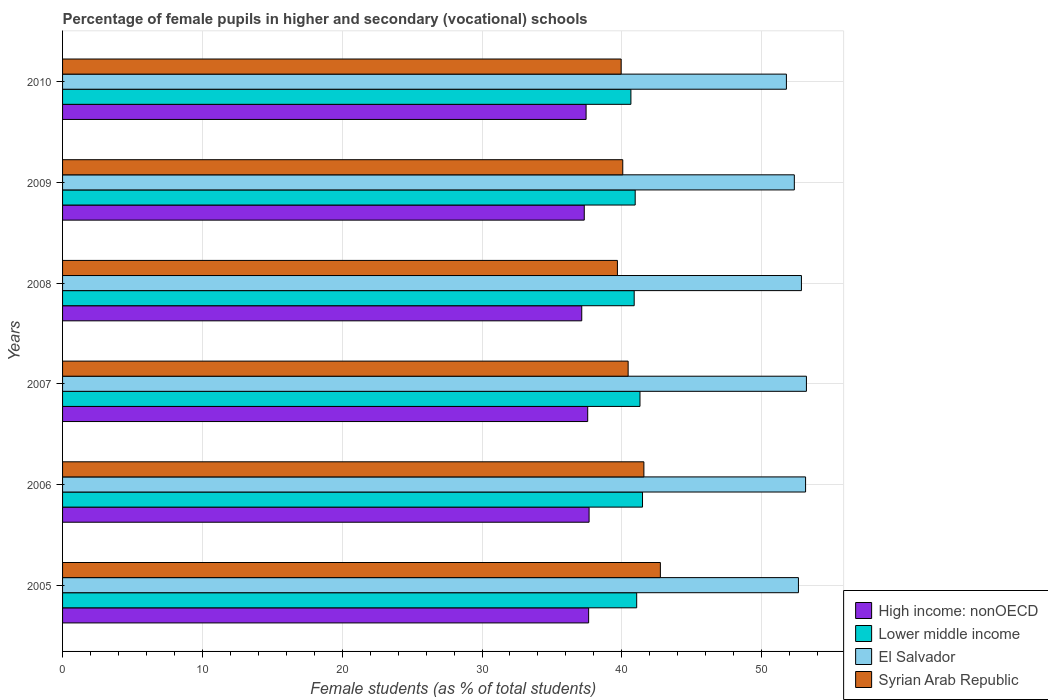Are the number of bars per tick equal to the number of legend labels?
Your response must be concise. Yes. What is the label of the 1st group of bars from the top?
Provide a short and direct response. 2010. What is the percentage of female pupils in higher and secondary schools in El Salvador in 2008?
Make the answer very short. 52.85. Across all years, what is the maximum percentage of female pupils in higher and secondary schools in Syrian Arab Republic?
Provide a short and direct response. 42.76. Across all years, what is the minimum percentage of female pupils in higher and secondary schools in High income: nonOECD?
Give a very brief answer. 37.14. In which year was the percentage of female pupils in higher and secondary schools in Lower middle income maximum?
Ensure brevity in your answer.  2006. In which year was the percentage of female pupils in higher and secondary schools in Lower middle income minimum?
Your answer should be compact. 2010. What is the total percentage of female pupils in higher and secondary schools in El Salvador in the graph?
Keep it short and to the point. 315.95. What is the difference between the percentage of female pupils in higher and secondary schools in Syrian Arab Republic in 2008 and that in 2010?
Keep it short and to the point. -0.27. What is the difference between the percentage of female pupils in higher and secondary schools in Syrian Arab Republic in 2008 and the percentage of female pupils in higher and secondary schools in El Salvador in 2007?
Keep it short and to the point. -13.52. What is the average percentage of female pupils in higher and secondary schools in High income: nonOECD per year?
Provide a short and direct response. 37.46. In the year 2009, what is the difference between the percentage of female pupils in higher and secondary schools in High income: nonOECD and percentage of female pupils in higher and secondary schools in Lower middle income?
Ensure brevity in your answer.  -3.64. What is the ratio of the percentage of female pupils in higher and secondary schools in Lower middle income in 2006 to that in 2007?
Provide a succinct answer. 1. Is the percentage of female pupils in higher and secondary schools in High income: nonOECD in 2008 less than that in 2010?
Make the answer very short. Yes. What is the difference between the highest and the second highest percentage of female pupils in higher and secondary schools in Syrian Arab Republic?
Provide a short and direct response. 1.18. What is the difference between the highest and the lowest percentage of female pupils in higher and secondary schools in Lower middle income?
Ensure brevity in your answer.  0.83. Is the sum of the percentage of female pupils in higher and secondary schools in Syrian Arab Republic in 2006 and 2007 greater than the maximum percentage of female pupils in higher and secondary schools in High income: nonOECD across all years?
Your answer should be very brief. Yes. What does the 4th bar from the top in 2008 represents?
Your answer should be very brief. High income: nonOECD. What does the 1st bar from the bottom in 2005 represents?
Offer a terse response. High income: nonOECD. Is it the case that in every year, the sum of the percentage of female pupils in higher and secondary schools in Syrian Arab Republic and percentage of female pupils in higher and secondary schools in El Salvador is greater than the percentage of female pupils in higher and secondary schools in High income: nonOECD?
Offer a very short reply. Yes. What is the difference between two consecutive major ticks on the X-axis?
Offer a terse response. 10. Does the graph contain grids?
Ensure brevity in your answer.  Yes. Where does the legend appear in the graph?
Your answer should be very brief. Bottom right. How many legend labels are there?
Offer a very short reply. 4. How are the legend labels stacked?
Offer a terse response. Vertical. What is the title of the graph?
Offer a very short reply. Percentage of female pupils in higher and secondary (vocational) schools. Does "Papua New Guinea" appear as one of the legend labels in the graph?
Keep it short and to the point. No. What is the label or title of the X-axis?
Provide a succinct answer. Female students (as % of total students). What is the label or title of the Y-axis?
Keep it short and to the point. Years. What is the Female students (as % of total students) in High income: nonOECD in 2005?
Give a very brief answer. 37.63. What is the Female students (as % of total students) of Lower middle income in 2005?
Ensure brevity in your answer.  41.06. What is the Female students (as % of total students) of El Salvador in 2005?
Provide a succinct answer. 52.63. What is the Female students (as % of total students) of Syrian Arab Republic in 2005?
Your response must be concise. 42.76. What is the Female students (as % of total students) of High income: nonOECD in 2006?
Give a very brief answer. 37.66. What is the Female students (as % of total students) in Lower middle income in 2006?
Keep it short and to the point. 41.48. What is the Female students (as % of total students) in El Salvador in 2006?
Ensure brevity in your answer.  53.14. What is the Female students (as % of total students) in Syrian Arab Republic in 2006?
Your response must be concise. 41.58. What is the Female students (as % of total students) of High income: nonOECD in 2007?
Provide a succinct answer. 37.56. What is the Female students (as % of total students) of Lower middle income in 2007?
Ensure brevity in your answer.  41.3. What is the Female students (as % of total students) in El Salvador in 2007?
Your response must be concise. 53.21. What is the Female students (as % of total students) in Syrian Arab Republic in 2007?
Provide a succinct answer. 40.45. What is the Female students (as % of total students) in High income: nonOECD in 2008?
Ensure brevity in your answer.  37.14. What is the Female students (as % of total students) of Lower middle income in 2008?
Offer a terse response. 40.89. What is the Female students (as % of total students) in El Salvador in 2008?
Ensure brevity in your answer.  52.85. What is the Female students (as % of total students) in Syrian Arab Republic in 2008?
Keep it short and to the point. 39.69. What is the Female students (as % of total students) of High income: nonOECD in 2009?
Your response must be concise. 37.31. What is the Female students (as % of total students) in Lower middle income in 2009?
Give a very brief answer. 40.96. What is the Female students (as % of total students) of El Salvador in 2009?
Your response must be concise. 52.34. What is the Female students (as % of total students) in Syrian Arab Republic in 2009?
Ensure brevity in your answer.  40.07. What is the Female students (as % of total students) of High income: nonOECD in 2010?
Offer a very short reply. 37.45. What is the Female students (as % of total students) in Lower middle income in 2010?
Offer a very short reply. 40.65. What is the Female students (as % of total students) of El Salvador in 2010?
Your response must be concise. 51.77. What is the Female students (as % of total students) of Syrian Arab Republic in 2010?
Provide a succinct answer. 39.95. Across all years, what is the maximum Female students (as % of total students) of High income: nonOECD?
Your response must be concise. 37.66. Across all years, what is the maximum Female students (as % of total students) of Lower middle income?
Offer a terse response. 41.48. Across all years, what is the maximum Female students (as % of total students) of El Salvador?
Your response must be concise. 53.21. Across all years, what is the maximum Female students (as % of total students) in Syrian Arab Republic?
Offer a very short reply. 42.76. Across all years, what is the minimum Female students (as % of total students) of High income: nonOECD?
Keep it short and to the point. 37.14. Across all years, what is the minimum Female students (as % of total students) in Lower middle income?
Make the answer very short. 40.65. Across all years, what is the minimum Female students (as % of total students) of El Salvador?
Provide a short and direct response. 51.77. Across all years, what is the minimum Female students (as % of total students) in Syrian Arab Republic?
Offer a terse response. 39.69. What is the total Female students (as % of total students) in High income: nonOECD in the graph?
Offer a terse response. 224.74. What is the total Female students (as % of total students) in Lower middle income in the graph?
Provide a succinct answer. 246.34. What is the total Female students (as % of total students) in El Salvador in the graph?
Offer a terse response. 315.95. What is the total Female students (as % of total students) of Syrian Arab Republic in the graph?
Your response must be concise. 244.5. What is the difference between the Female students (as % of total students) of High income: nonOECD in 2005 and that in 2006?
Keep it short and to the point. -0.03. What is the difference between the Female students (as % of total students) of Lower middle income in 2005 and that in 2006?
Your answer should be very brief. -0.42. What is the difference between the Female students (as % of total students) of El Salvador in 2005 and that in 2006?
Your answer should be very brief. -0.51. What is the difference between the Female students (as % of total students) in Syrian Arab Republic in 2005 and that in 2006?
Ensure brevity in your answer.  1.18. What is the difference between the Female students (as % of total students) in High income: nonOECD in 2005 and that in 2007?
Give a very brief answer. 0.07. What is the difference between the Female students (as % of total students) of Lower middle income in 2005 and that in 2007?
Your response must be concise. -0.24. What is the difference between the Female students (as % of total students) of El Salvador in 2005 and that in 2007?
Make the answer very short. -0.57. What is the difference between the Female students (as % of total students) in Syrian Arab Republic in 2005 and that in 2007?
Give a very brief answer. 2.31. What is the difference between the Female students (as % of total students) in High income: nonOECD in 2005 and that in 2008?
Keep it short and to the point. 0.49. What is the difference between the Female students (as % of total students) of Lower middle income in 2005 and that in 2008?
Offer a terse response. 0.18. What is the difference between the Female students (as % of total students) of El Salvador in 2005 and that in 2008?
Keep it short and to the point. -0.22. What is the difference between the Female students (as % of total students) in Syrian Arab Republic in 2005 and that in 2008?
Ensure brevity in your answer.  3.07. What is the difference between the Female students (as % of total students) in High income: nonOECD in 2005 and that in 2009?
Your response must be concise. 0.31. What is the difference between the Female students (as % of total students) of Lower middle income in 2005 and that in 2009?
Offer a terse response. 0.11. What is the difference between the Female students (as % of total students) of El Salvador in 2005 and that in 2009?
Your response must be concise. 0.29. What is the difference between the Female students (as % of total students) in Syrian Arab Republic in 2005 and that in 2009?
Offer a very short reply. 2.69. What is the difference between the Female students (as % of total students) in High income: nonOECD in 2005 and that in 2010?
Offer a terse response. 0.18. What is the difference between the Female students (as % of total students) of Lower middle income in 2005 and that in 2010?
Provide a succinct answer. 0.41. What is the difference between the Female students (as % of total students) of El Salvador in 2005 and that in 2010?
Your answer should be very brief. 0.86. What is the difference between the Female students (as % of total students) in Syrian Arab Republic in 2005 and that in 2010?
Offer a terse response. 2.81. What is the difference between the Female students (as % of total students) of High income: nonOECD in 2006 and that in 2007?
Ensure brevity in your answer.  0.1. What is the difference between the Female students (as % of total students) in Lower middle income in 2006 and that in 2007?
Your answer should be compact. 0.18. What is the difference between the Female students (as % of total students) of El Salvador in 2006 and that in 2007?
Ensure brevity in your answer.  -0.06. What is the difference between the Female students (as % of total students) of Syrian Arab Republic in 2006 and that in 2007?
Offer a very short reply. 1.13. What is the difference between the Female students (as % of total students) of High income: nonOECD in 2006 and that in 2008?
Offer a very short reply. 0.52. What is the difference between the Female students (as % of total students) in Lower middle income in 2006 and that in 2008?
Give a very brief answer. 0.6. What is the difference between the Female students (as % of total students) of El Salvador in 2006 and that in 2008?
Your response must be concise. 0.3. What is the difference between the Female students (as % of total students) of Syrian Arab Republic in 2006 and that in 2008?
Give a very brief answer. 1.89. What is the difference between the Female students (as % of total students) of High income: nonOECD in 2006 and that in 2009?
Offer a very short reply. 0.35. What is the difference between the Female students (as % of total students) in Lower middle income in 2006 and that in 2009?
Ensure brevity in your answer.  0.52. What is the difference between the Female students (as % of total students) in El Salvador in 2006 and that in 2009?
Keep it short and to the point. 0.8. What is the difference between the Female students (as % of total students) of Syrian Arab Republic in 2006 and that in 2009?
Provide a short and direct response. 1.51. What is the difference between the Female students (as % of total students) of High income: nonOECD in 2006 and that in 2010?
Ensure brevity in your answer.  0.21. What is the difference between the Female students (as % of total students) of Lower middle income in 2006 and that in 2010?
Give a very brief answer. 0.83. What is the difference between the Female students (as % of total students) in El Salvador in 2006 and that in 2010?
Offer a very short reply. 1.37. What is the difference between the Female students (as % of total students) in Syrian Arab Republic in 2006 and that in 2010?
Offer a terse response. 1.63. What is the difference between the Female students (as % of total students) in High income: nonOECD in 2007 and that in 2008?
Offer a terse response. 0.42. What is the difference between the Female students (as % of total students) in Lower middle income in 2007 and that in 2008?
Make the answer very short. 0.41. What is the difference between the Female students (as % of total students) in El Salvador in 2007 and that in 2008?
Make the answer very short. 0.36. What is the difference between the Female students (as % of total students) of Syrian Arab Republic in 2007 and that in 2008?
Your answer should be very brief. 0.77. What is the difference between the Female students (as % of total students) in High income: nonOECD in 2007 and that in 2009?
Offer a terse response. 0.25. What is the difference between the Female students (as % of total students) in Lower middle income in 2007 and that in 2009?
Give a very brief answer. 0.34. What is the difference between the Female students (as % of total students) of El Salvador in 2007 and that in 2009?
Offer a very short reply. 0.87. What is the difference between the Female students (as % of total students) of Syrian Arab Republic in 2007 and that in 2009?
Your answer should be compact. 0.38. What is the difference between the Female students (as % of total students) of High income: nonOECD in 2007 and that in 2010?
Give a very brief answer. 0.12. What is the difference between the Female students (as % of total students) of Lower middle income in 2007 and that in 2010?
Your answer should be very brief. 0.65. What is the difference between the Female students (as % of total students) of El Salvador in 2007 and that in 2010?
Give a very brief answer. 1.43. What is the difference between the Female students (as % of total students) in Syrian Arab Republic in 2007 and that in 2010?
Offer a very short reply. 0.5. What is the difference between the Female students (as % of total students) in High income: nonOECD in 2008 and that in 2009?
Make the answer very short. -0.18. What is the difference between the Female students (as % of total students) of Lower middle income in 2008 and that in 2009?
Make the answer very short. -0.07. What is the difference between the Female students (as % of total students) in El Salvador in 2008 and that in 2009?
Your answer should be very brief. 0.51. What is the difference between the Female students (as % of total students) in Syrian Arab Republic in 2008 and that in 2009?
Provide a short and direct response. -0.38. What is the difference between the Female students (as % of total students) in High income: nonOECD in 2008 and that in 2010?
Provide a short and direct response. -0.31. What is the difference between the Female students (as % of total students) in Lower middle income in 2008 and that in 2010?
Make the answer very short. 0.23. What is the difference between the Female students (as % of total students) in El Salvador in 2008 and that in 2010?
Offer a terse response. 1.08. What is the difference between the Female students (as % of total students) of Syrian Arab Republic in 2008 and that in 2010?
Your answer should be very brief. -0.27. What is the difference between the Female students (as % of total students) in High income: nonOECD in 2009 and that in 2010?
Your response must be concise. -0.13. What is the difference between the Female students (as % of total students) of Lower middle income in 2009 and that in 2010?
Make the answer very short. 0.31. What is the difference between the Female students (as % of total students) of El Salvador in 2009 and that in 2010?
Make the answer very short. 0.57. What is the difference between the Female students (as % of total students) of Syrian Arab Republic in 2009 and that in 2010?
Provide a succinct answer. 0.12. What is the difference between the Female students (as % of total students) of High income: nonOECD in 2005 and the Female students (as % of total students) of Lower middle income in 2006?
Keep it short and to the point. -3.85. What is the difference between the Female students (as % of total students) of High income: nonOECD in 2005 and the Female students (as % of total students) of El Salvador in 2006?
Keep it short and to the point. -15.52. What is the difference between the Female students (as % of total students) of High income: nonOECD in 2005 and the Female students (as % of total students) of Syrian Arab Republic in 2006?
Provide a short and direct response. -3.95. What is the difference between the Female students (as % of total students) in Lower middle income in 2005 and the Female students (as % of total students) in El Salvador in 2006?
Give a very brief answer. -12.08. What is the difference between the Female students (as % of total students) in Lower middle income in 2005 and the Female students (as % of total students) in Syrian Arab Republic in 2006?
Your answer should be compact. -0.52. What is the difference between the Female students (as % of total students) in El Salvador in 2005 and the Female students (as % of total students) in Syrian Arab Republic in 2006?
Make the answer very short. 11.05. What is the difference between the Female students (as % of total students) of High income: nonOECD in 2005 and the Female students (as % of total students) of Lower middle income in 2007?
Provide a short and direct response. -3.67. What is the difference between the Female students (as % of total students) of High income: nonOECD in 2005 and the Female students (as % of total students) of El Salvador in 2007?
Offer a very short reply. -15.58. What is the difference between the Female students (as % of total students) of High income: nonOECD in 2005 and the Female students (as % of total students) of Syrian Arab Republic in 2007?
Offer a very short reply. -2.82. What is the difference between the Female students (as % of total students) in Lower middle income in 2005 and the Female students (as % of total students) in El Salvador in 2007?
Make the answer very short. -12.14. What is the difference between the Female students (as % of total students) in Lower middle income in 2005 and the Female students (as % of total students) in Syrian Arab Republic in 2007?
Make the answer very short. 0.61. What is the difference between the Female students (as % of total students) in El Salvador in 2005 and the Female students (as % of total students) in Syrian Arab Republic in 2007?
Offer a very short reply. 12.18. What is the difference between the Female students (as % of total students) in High income: nonOECD in 2005 and the Female students (as % of total students) in Lower middle income in 2008?
Offer a terse response. -3.26. What is the difference between the Female students (as % of total students) of High income: nonOECD in 2005 and the Female students (as % of total students) of El Salvador in 2008?
Offer a very short reply. -15.22. What is the difference between the Female students (as % of total students) of High income: nonOECD in 2005 and the Female students (as % of total students) of Syrian Arab Republic in 2008?
Give a very brief answer. -2.06. What is the difference between the Female students (as % of total students) in Lower middle income in 2005 and the Female students (as % of total students) in El Salvador in 2008?
Provide a succinct answer. -11.78. What is the difference between the Female students (as % of total students) of Lower middle income in 2005 and the Female students (as % of total students) of Syrian Arab Republic in 2008?
Give a very brief answer. 1.38. What is the difference between the Female students (as % of total students) in El Salvador in 2005 and the Female students (as % of total students) in Syrian Arab Republic in 2008?
Provide a succinct answer. 12.95. What is the difference between the Female students (as % of total students) in High income: nonOECD in 2005 and the Female students (as % of total students) in Lower middle income in 2009?
Keep it short and to the point. -3.33. What is the difference between the Female students (as % of total students) in High income: nonOECD in 2005 and the Female students (as % of total students) in El Salvador in 2009?
Offer a terse response. -14.71. What is the difference between the Female students (as % of total students) in High income: nonOECD in 2005 and the Female students (as % of total students) in Syrian Arab Republic in 2009?
Provide a short and direct response. -2.44. What is the difference between the Female students (as % of total students) of Lower middle income in 2005 and the Female students (as % of total students) of El Salvador in 2009?
Provide a succinct answer. -11.28. What is the difference between the Female students (as % of total students) of El Salvador in 2005 and the Female students (as % of total students) of Syrian Arab Republic in 2009?
Keep it short and to the point. 12.56. What is the difference between the Female students (as % of total students) in High income: nonOECD in 2005 and the Female students (as % of total students) in Lower middle income in 2010?
Give a very brief answer. -3.02. What is the difference between the Female students (as % of total students) in High income: nonOECD in 2005 and the Female students (as % of total students) in El Salvador in 2010?
Keep it short and to the point. -14.15. What is the difference between the Female students (as % of total students) of High income: nonOECD in 2005 and the Female students (as % of total students) of Syrian Arab Republic in 2010?
Make the answer very short. -2.33. What is the difference between the Female students (as % of total students) of Lower middle income in 2005 and the Female students (as % of total students) of El Salvador in 2010?
Keep it short and to the point. -10.71. What is the difference between the Female students (as % of total students) of Lower middle income in 2005 and the Female students (as % of total students) of Syrian Arab Republic in 2010?
Keep it short and to the point. 1.11. What is the difference between the Female students (as % of total students) in El Salvador in 2005 and the Female students (as % of total students) in Syrian Arab Republic in 2010?
Your response must be concise. 12.68. What is the difference between the Female students (as % of total students) in High income: nonOECD in 2006 and the Female students (as % of total students) in Lower middle income in 2007?
Make the answer very short. -3.64. What is the difference between the Female students (as % of total students) in High income: nonOECD in 2006 and the Female students (as % of total students) in El Salvador in 2007?
Offer a very short reply. -15.54. What is the difference between the Female students (as % of total students) in High income: nonOECD in 2006 and the Female students (as % of total students) in Syrian Arab Republic in 2007?
Your answer should be very brief. -2.79. What is the difference between the Female students (as % of total students) in Lower middle income in 2006 and the Female students (as % of total students) in El Salvador in 2007?
Ensure brevity in your answer.  -11.72. What is the difference between the Female students (as % of total students) of Lower middle income in 2006 and the Female students (as % of total students) of Syrian Arab Republic in 2007?
Ensure brevity in your answer.  1.03. What is the difference between the Female students (as % of total students) in El Salvador in 2006 and the Female students (as % of total students) in Syrian Arab Republic in 2007?
Provide a short and direct response. 12.69. What is the difference between the Female students (as % of total students) in High income: nonOECD in 2006 and the Female students (as % of total students) in Lower middle income in 2008?
Keep it short and to the point. -3.23. What is the difference between the Female students (as % of total students) of High income: nonOECD in 2006 and the Female students (as % of total students) of El Salvador in 2008?
Your response must be concise. -15.19. What is the difference between the Female students (as % of total students) in High income: nonOECD in 2006 and the Female students (as % of total students) in Syrian Arab Republic in 2008?
Keep it short and to the point. -2.03. What is the difference between the Female students (as % of total students) of Lower middle income in 2006 and the Female students (as % of total students) of El Salvador in 2008?
Provide a succinct answer. -11.37. What is the difference between the Female students (as % of total students) in Lower middle income in 2006 and the Female students (as % of total students) in Syrian Arab Republic in 2008?
Your response must be concise. 1.79. What is the difference between the Female students (as % of total students) in El Salvador in 2006 and the Female students (as % of total students) in Syrian Arab Republic in 2008?
Your answer should be very brief. 13.46. What is the difference between the Female students (as % of total students) of High income: nonOECD in 2006 and the Female students (as % of total students) of Lower middle income in 2009?
Give a very brief answer. -3.3. What is the difference between the Female students (as % of total students) of High income: nonOECD in 2006 and the Female students (as % of total students) of El Salvador in 2009?
Keep it short and to the point. -14.68. What is the difference between the Female students (as % of total students) in High income: nonOECD in 2006 and the Female students (as % of total students) in Syrian Arab Republic in 2009?
Provide a short and direct response. -2.41. What is the difference between the Female students (as % of total students) of Lower middle income in 2006 and the Female students (as % of total students) of El Salvador in 2009?
Offer a very short reply. -10.86. What is the difference between the Female students (as % of total students) in Lower middle income in 2006 and the Female students (as % of total students) in Syrian Arab Republic in 2009?
Give a very brief answer. 1.41. What is the difference between the Female students (as % of total students) in El Salvador in 2006 and the Female students (as % of total students) in Syrian Arab Republic in 2009?
Provide a short and direct response. 13.08. What is the difference between the Female students (as % of total students) of High income: nonOECD in 2006 and the Female students (as % of total students) of Lower middle income in 2010?
Your answer should be compact. -2.99. What is the difference between the Female students (as % of total students) of High income: nonOECD in 2006 and the Female students (as % of total students) of El Salvador in 2010?
Your answer should be very brief. -14.11. What is the difference between the Female students (as % of total students) of High income: nonOECD in 2006 and the Female students (as % of total students) of Syrian Arab Republic in 2010?
Your answer should be compact. -2.29. What is the difference between the Female students (as % of total students) of Lower middle income in 2006 and the Female students (as % of total students) of El Salvador in 2010?
Offer a terse response. -10.29. What is the difference between the Female students (as % of total students) of Lower middle income in 2006 and the Female students (as % of total students) of Syrian Arab Republic in 2010?
Ensure brevity in your answer.  1.53. What is the difference between the Female students (as % of total students) of El Salvador in 2006 and the Female students (as % of total students) of Syrian Arab Republic in 2010?
Your answer should be compact. 13.19. What is the difference between the Female students (as % of total students) of High income: nonOECD in 2007 and the Female students (as % of total students) of Lower middle income in 2008?
Offer a terse response. -3.33. What is the difference between the Female students (as % of total students) of High income: nonOECD in 2007 and the Female students (as % of total students) of El Salvador in 2008?
Provide a succinct answer. -15.29. What is the difference between the Female students (as % of total students) of High income: nonOECD in 2007 and the Female students (as % of total students) of Syrian Arab Republic in 2008?
Keep it short and to the point. -2.13. What is the difference between the Female students (as % of total students) in Lower middle income in 2007 and the Female students (as % of total students) in El Salvador in 2008?
Make the answer very short. -11.55. What is the difference between the Female students (as % of total students) of Lower middle income in 2007 and the Female students (as % of total students) of Syrian Arab Republic in 2008?
Your answer should be compact. 1.61. What is the difference between the Female students (as % of total students) in El Salvador in 2007 and the Female students (as % of total students) in Syrian Arab Republic in 2008?
Provide a short and direct response. 13.52. What is the difference between the Female students (as % of total students) in High income: nonOECD in 2007 and the Female students (as % of total students) in Lower middle income in 2009?
Your answer should be very brief. -3.4. What is the difference between the Female students (as % of total students) in High income: nonOECD in 2007 and the Female students (as % of total students) in El Salvador in 2009?
Ensure brevity in your answer.  -14.78. What is the difference between the Female students (as % of total students) in High income: nonOECD in 2007 and the Female students (as % of total students) in Syrian Arab Republic in 2009?
Offer a very short reply. -2.51. What is the difference between the Female students (as % of total students) in Lower middle income in 2007 and the Female students (as % of total students) in El Salvador in 2009?
Your answer should be compact. -11.04. What is the difference between the Female students (as % of total students) of Lower middle income in 2007 and the Female students (as % of total students) of Syrian Arab Republic in 2009?
Ensure brevity in your answer.  1.23. What is the difference between the Female students (as % of total students) of El Salvador in 2007 and the Female students (as % of total students) of Syrian Arab Republic in 2009?
Your response must be concise. 13.14. What is the difference between the Female students (as % of total students) of High income: nonOECD in 2007 and the Female students (as % of total students) of Lower middle income in 2010?
Keep it short and to the point. -3.09. What is the difference between the Female students (as % of total students) of High income: nonOECD in 2007 and the Female students (as % of total students) of El Salvador in 2010?
Ensure brevity in your answer.  -14.21. What is the difference between the Female students (as % of total students) of High income: nonOECD in 2007 and the Female students (as % of total students) of Syrian Arab Republic in 2010?
Make the answer very short. -2.39. What is the difference between the Female students (as % of total students) in Lower middle income in 2007 and the Female students (as % of total students) in El Salvador in 2010?
Offer a terse response. -10.47. What is the difference between the Female students (as % of total students) in Lower middle income in 2007 and the Female students (as % of total students) in Syrian Arab Republic in 2010?
Your answer should be compact. 1.35. What is the difference between the Female students (as % of total students) in El Salvador in 2007 and the Female students (as % of total students) in Syrian Arab Republic in 2010?
Provide a succinct answer. 13.25. What is the difference between the Female students (as % of total students) of High income: nonOECD in 2008 and the Female students (as % of total students) of Lower middle income in 2009?
Your response must be concise. -3.82. What is the difference between the Female students (as % of total students) in High income: nonOECD in 2008 and the Female students (as % of total students) in El Salvador in 2009?
Offer a terse response. -15.2. What is the difference between the Female students (as % of total students) in High income: nonOECD in 2008 and the Female students (as % of total students) in Syrian Arab Republic in 2009?
Offer a terse response. -2.93. What is the difference between the Female students (as % of total students) of Lower middle income in 2008 and the Female students (as % of total students) of El Salvador in 2009?
Give a very brief answer. -11.45. What is the difference between the Female students (as % of total students) of Lower middle income in 2008 and the Female students (as % of total students) of Syrian Arab Republic in 2009?
Your answer should be compact. 0.82. What is the difference between the Female students (as % of total students) in El Salvador in 2008 and the Female students (as % of total students) in Syrian Arab Republic in 2009?
Your answer should be compact. 12.78. What is the difference between the Female students (as % of total students) in High income: nonOECD in 2008 and the Female students (as % of total students) in Lower middle income in 2010?
Provide a succinct answer. -3.52. What is the difference between the Female students (as % of total students) of High income: nonOECD in 2008 and the Female students (as % of total students) of El Salvador in 2010?
Make the answer very short. -14.64. What is the difference between the Female students (as % of total students) of High income: nonOECD in 2008 and the Female students (as % of total students) of Syrian Arab Republic in 2010?
Provide a succinct answer. -2.82. What is the difference between the Female students (as % of total students) of Lower middle income in 2008 and the Female students (as % of total students) of El Salvador in 2010?
Provide a short and direct response. -10.89. What is the difference between the Female students (as % of total students) of Lower middle income in 2008 and the Female students (as % of total students) of Syrian Arab Republic in 2010?
Your answer should be very brief. 0.93. What is the difference between the Female students (as % of total students) in El Salvador in 2008 and the Female students (as % of total students) in Syrian Arab Republic in 2010?
Offer a terse response. 12.89. What is the difference between the Female students (as % of total students) in High income: nonOECD in 2009 and the Female students (as % of total students) in Lower middle income in 2010?
Ensure brevity in your answer.  -3.34. What is the difference between the Female students (as % of total students) of High income: nonOECD in 2009 and the Female students (as % of total students) of El Salvador in 2010?
Your response must be concise. -14.46. What is the difference between the Female students (as % of total students) of High income: nonOECD in 2009 and the Female students (as % of total students) of Syrian Arab Republic in 2010?
Your answer should be very brief. -2.64. What is the difference between the Female students (as % of total students) of Lower middle income in 2009 and the Female students (as % of total students) of El Salvador in 2010?
Give a very brief answer. -10.82. What is the difference between the Female students (as % of total students) of El Salvador in 2009 and the Female students (as % of total students) of Syrian Arab Republic in 2010?
Provide a short and direct response. 12.39. What is the average Female students (as % of total students) in High income: nonOECD per year?
Your response must be concise. 37.46. What is the average Female students (as % of total students) of Lower middle income per year?
Give a very brief answer. 41.06. What is the average Female students (as % of total students) in El Salvador per year?
Your answer should be very brief. 52.66. What is the average Female students (as % of total students) in Syrian Arab Republic per year?
Offer a very short reply. 40.75. In the year 2005, what is the difference between the Female students (as % of total students) in High income: nonOECD and Female students (as % of total students) in Lower middle income?
Ensure brevity in your answer.  -3.44. In the year 2005, what is the difference between the Female students (as % of total students) of High income: nonOECD and Female students (as % of total students) of El Salvador?
Ensure brevity in your answer.  -15.01. In the year 2005, what is the difference between the Female students (as % of total students) in High income: nonOECD and Female students (as % of total students) in Syrian Arab Republic?
Offer a terse response. -5.13. In the year 2005, what is the difference between the Female students (as % of total students) of Lower middle income and Female students (as % of total students) of El Salvador?
Provide a short and direct response. -11.57. In the year 2005, what is the difference between the Female students (as % of total students) of Lower middle income and Female students (as % of total students) of Syrian Arab Republic?
Your answer should be compact. -1.69. In the year 2005, what is the difference between the Female students (as % of total students) of El Salvador and Female students (as % of total students) of Syrian Arab Republic?
Keep it short and to the point. 9.87. In the year 2006, what is the difference between the Female students (as % of total students) of High income: nonOECD and Female students (as % of total students) of Lower middle income?
Your answer should be very brief. -3.82. In the year 2006, what is the difference between the Female students (as % of total students) of High income: nonOECD and Female students (as % of total students) of El Salvador?
Offer a very short reply. -15.48. In the year 2006, what is the difference between the Female students (as % of total students) in High income: nonOECD and Female students (as % of total students) in Syrian Arab Republic?
Give a very brief answer. -3.92. In the year 2006, what is the difference between the Female students (as % of total students) of Lower middle income and Female students (as % of total students) of El Salvador?
Provide a succinct answer. -11.66. In the year 2006, what is the difference between the Female students (as % of total students) in Lower middle income and Female students (as % of total students) in Syrian Arab Republic?
Ensure brevity in your answer.  -0.1. In the year 2006, what is the difference between the Female students (as % of total students) in El Salvador and Female students (as % of total students) in Syrian Arab Republic?
Your response must be concise. 11.57. In the year 2007, what is the difference between the Female students (as % of total students) of High income: nonOECD and Female students (as % of total students) of Lower middle income?
Provide a short and direct response. -3.74. In the year 2007, what is the difference between the Female students (as % of total students) in High income: nonOECD and Female students (as % of total students) in El Salvador?
Make the answer very short. -15.64. In the year 2007, what is the difference between the Female students (as % of total students) in High income: nonOECD and Female students (as % of total students) in Syrian Arab Republic?
Your answer should be compact. -2.89. In the year 2007, what is the difference between the Female students (as % of total students) of Lower middle income and Female students (as % of total students) of El Salvador?
Your answer should be very brief. -11.9. In the year 2007, what is the difference between the Female students (as % of total students) in Lower middle income and Female students (as % of total students) in Syrian Arab Republic?
Make the answer very short. 0.85. In the year 2007, what is the difference between the Female students (as % of total students) of El Salvador and Female students (as % of total students) of Syrian Arab Republic?
Provide a succinct answer. 12.75. In the year 2008, what is the difference between the Female students (as % of total students) in High income: nonOECD and Female students (as % of total students) in Lower middle income?
Offer a very short reply. -3.75. In the year 2008, what is the difference between the Female students (as % of total students) in High income: nonOECD and Female students (as % of total students) in El Salvador?
Give a very brief answer. -15.71. In the year 2008, what is the difference between the Female students (as % of total students) of High income: nonOECD and Female students (as % of total students) of Syrian Arab Republic?
Your response must be concise. -2.55. In the year 2008, what is the difference between the Female students (as % of total students) in Lower middle income and Female students (as % of total students) in El Salvador?
Ensure brevity in your answer.  -11.96. In the year 2008, what is the difference between the Female students (as % of total students) of Lower middle income and Female students (as % of total students) of Syrian Arab Republic?
Your answer should be compact. 1.2. In the year 2008, what is the difference between the Female students (as % of total students) in El Salvador and Female students (as % of total students) in Syrian Arab Republic?
Your answer should be compact. 13.16. In the year 2009, what is the difference between the Female students (as % of total students) in High income: nonOECD and Female students (as % of total students) in Lower middle income?
Ensure brevity in your answer.  -3.64. In the year 2009, what is the difference between the Female students (as % of total students) in High income: nonOECD and Female students (as % of total students) in El Salvador?
Provide a short and direct response. -15.03. In the year 2009, what is the difference between the Female students (as % of total students) of High income: nonOECD and Female students (as % of total students) of Syrian Arab Republic?
Your answer should be compact. -2.75. In the year 2009, what is the difference between the Female students (as % of total students) in Lower middle income and Female students (as % of total students) in El Salvador?
Your answer should be very brief. -11.38. In the year 2009, what is the difference between the Female students (as % of total students) in Lower middle income and Female students (as % of total students) in Syrian Arab Republic?
Provide a short and direct response. 0.89. In the year 2009, what is the difference between the Female students (as % of total students) in El Salvador and Female students (as % of total students) in Syrian Arab Republic?
Offer a terse response. 12.27. In the year 2010, what is the difference between the Female students (as % of total students) in High income: nonOECD and Female students (as % of total students) in Lower middle income?
Provide a succinct answer. -3.21. In the year 2010, what is the difference between the Female students (as % of total students) in High income: nonOECD and Female students (as % of total students) in El Salvador?
Your answer should be very brief. -14.33. In the year 2010, what is the difference between the Female students (as % of total students) of High income: nonOECD and Female students (as % of total students) of Syrian Arab Republic?
Keep it short and to the point. -2.51. In the year 2010, what is the difference between the Female students (as % of total students) of Lower middle income and Female students (as % of total students) of El Salvador?
Keep it short and to the point. -11.12. In the year 2010, what is the difference between the Female students (as % of total students) of Lower middle income and Female students (as % of total students) of Syrian Arab Republic?
Make the answer very short. 0.7. In the year 2010, what is the difference between the Female students (as % of total students) of El Salvador and Female students (as % of total students) of Syrian Arab Republic?
Offer a very short reply. 11.82. What is the ratio of the Female students (as % of total students) in Syrian Arab Republic in 2005 to that in 2006?
Ensure brevity in your answer.  1.03. What is the ratio of the Female students (as % of total students) of High income: nonOECD in 2005 to that in 2007?
Offer a very short reply. 1. What is the ratio of the Female students (as % of total students) of Lower middle income in 2005 to that in 2007?
Keep it short and to the point. 0.99. What is the ratio of the Female students (as % of total students) of El Salvador in 2005 to that in 2007?
Make the answer very short. 0.99. What is the ratio of the Female students (as % of total students) in Syrian Arab Republic in 2005 to that in 2007?
Offer a very short reply. 1.06. What is the ratio of the Female students (as % of total students) of High income: nonOECD in 2005 to that in 2008?
Offer a terse response. 1.01. What is the ratio of the Female students (as % of total students) of El Salvador in 2005 to that in 2008?
Keep it short and to the point. 1. What is the ratio of the Female students (as % of total students) of Syrian Arab Republic in 2005 to that in 2008?
Offer a very short reply. 1.08. What is the ratio of the Female students (as % of total students) in High income: nonOECD in 2005 to that in 2009?
Provide a short and direct response. 1.01. What is the ratio of the Female students (as % of total students) in Lower middle income in 2005 to that in 2009?
Offer a very short reply. 1. What is the ratio of the Female students (as % of total students) of El Salvador in 2005 to that in 2009?
Provide a short and direct response. 1.01. What is the ratio of the Female students (as % of total students) of Syrian Arab Republic in 2005 to that in 2009?
Make the answer very short. 1.07. What is the ratio of the Female students (as % of total students) of High income: nonOECD in 2005 to that in 2010?
Provide a succinct answer. 1. What is the ratio of the Female students (as % of total students) in Lower middle income in 2005 to that in 2010?
Provide a succinct answer. 1.01. What is the ratio of the Female students (as % of total students) of El Salvador in 2005 to that in 2010?
Offer a terse response. 1.02. What is the ratio of the Female students (as % of total students) in Syrian Arab Republic in 2005 to that in 2010?
Your answer should be compact. 1.07. What is the ratio of the Female students (as % of total students) in High income: nonOECD in 2006 to that in 2007?
Provide a succinct answer. 1. What is the ratio of the Female students (as % of total students) in Lower middle income in 2006 to that in 2007?
Offer a terse response. 1. What is the ratio of the Female students (as % of total students) in Syrian Arab Republic in 2006 to that in 2007?
Keep it short and to the point. 1.03. What is the ratio of the Female students (as % of total students) of High income: nonOECD in 2006 to that in 2008?
Keep it short and to the point. 1.01. What is the ratio of the Female students (as % of total students) in Lower middle income in 2006 to that in 2008?
Offer a terse response. 1.01. What is the ratio of the Female students (as % of total students) of El Salvador in 2006 to that in 2008?
Make the answer very short. 1.01. What is the ratio of the Female students (as % of total students) in Syrian Arab Republic in 2006 to that in 2008?
Offer a very short reply. 1.05. What is the ratio of the Female students (as % of total students) of High income: nonOECD in 2006 to that in 2009?
Make the answer very short. 1.01. What is the ratio of the Female students (as % of total students) in Lower middle income in 2006 to that in 2009?
Give a very brief answer. 1.01. What is the ratio of the Female students (as % of total students) of El Salvador in 2006 to that in 2009?
Give a very brief answer. 1.02. What is the ratio of the Female students (as % of total students) of Syrian Arab Republic in 2006 to that in 2009?
Provide a succinct answer. 1.04. What is the ratio of the Female students (as % of total students) of Lower middle income in 2006 to that in 2010?
Provide a succinct answer. 1.02. What is the ratio of the Female students (as % of total students) of El Salvador in 2006 to that in 2010?
Provide a short and direct response. 1.03. What is the ratio of the Female students (as % of total students) of Syrian Arab Republic in 2006 to that in 2010?
Your response must be concise. 1.04. What is the ratio of the Female students (as % of total students) of High income: nonOECD in 2007 to that in 2008?
Give a very brief answer. 1.01. What is the ratio of the Female students (as % of total students) of El Salvador in 2007 to that in 2008?
Your response must be concise. 1.01. What is the ratio of the Female students (as % of total students) of Syrian Arab Republic in 2007 to that in 2008?
Offer a terse response. 1.02. What is the ratio of the Female students (as % of total students) of High income: nonOECD in 2007 to that in 2009?
Make the answer very short. 1.01. What is the ratio of the Female students (as % of total students) of Lower middle income in 2007 to that in 2009?
Offer a very short reply. 1.01. What is the ratio of the Female students (as % of total students) of El Salvador in 2007 to that in 2009?
Make the answer very short. 1.02. What is the ratio of the Female students (as % of total students) of Syrian Arab Republic in 2007 to that in 2009?
Provide a succinct answer. 1.01. What is the ratio of the Female students (as % of total students) of El Salvador in 2007 to that in 2010?
Your response must be concise. 1.03. What is the ratio of the Female students (as % of total students) in Syrian Arab Republic in 2007 to that in 2010?
Offer a terse response. 1.01. What is the ratio of the Female students (as % of total students) in High income: nonOECD in 2008 to that in 2009?
Keep it short and to the point. 1. What is the ratio of the Female students (as % of total students) of El Salvador in 2008 to that in 2009?
Provide a succinct answer. 1.01. What is the ratio of the Female students (as % of total students) in Syrian Arab Republic in 2008 to that in 2009?
Your response must be concise. 0.99. What is the ratio of the Female students (as % of total students) of Lower middle income in 2008 to that in 2010?
Provide a succinct answer. 1.01. What is the ratio of the Female students (as % of total students) of El Salvador in 2008 to that in 2010?
Give a very brief answer. 1.02. What is the ratio of the Female students (as % of total students) of Syrian Arab Republic in 2008 to that in 2010?
Provide a succinct answer. 0.99. What is the ratio of the Female students (as % of total students) in High income: nonOECD in 2009 to that in 2010?
Your answer should be compact. 1. What is the ratio of the Female students (as % of total students) of Lower middle income in 2009 to that in 2010?
Provide a succinct answer. 1.01. What is the ratio of the Female students (as % of total students) of El Salvador in 2009 to that in 2010?
Offer a very short reply. 1.01. What is the ratio of the Female students (as % of total students) of Syrian Arab Republic in 2009 to that in 2010?
Provide a succinct answer. 1. What is the difference between the highest and the second highest Female students (as % of total students) in High income: nonOECD?
Offer a terse response. 0.03. What is the difference between the highest and the second highest Female students (as % of total students) in Lower middle income?
Make the answer very short. 0.18. What is the difference between the highest and the second highest Female students (as % of total students) in El Salvador?
Give a very brief answer. 0.06. What is the difference between the highest and the second highest Female students (as % of total students) of Syrian Arab Republic?
Make the answer very short. 1.18. What is the difference between the highest and the lowest Female students (as % of total students) in High income: nonOECD?
Ensure brevity in your answer.  0.52. What is the difference between the highest and the lowest Female students (as % of total students) of Lower middle income?
Your answer should be very brief. 0.83. What is the difference between the highest and the lowest Female students (as % of total students) of El Salvador?
Keep it short and to the point. 1.43. What is the difference between the highest and the lowest Female students (as % of total students) in Syrian Arab Republic?
Provide a short and direct response. 3.07. 